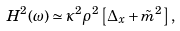Convert formula to latex. <formula><loc_0><loc_0><loc_500><loc_500>H ^ { 2 } ( \omega ) \simeq \kappa ^ { 2 } \rho ^ { 2 } \left [ \Delta _ { x } + \tilde { m } ^ { 2 } \right ] ,</formula> 